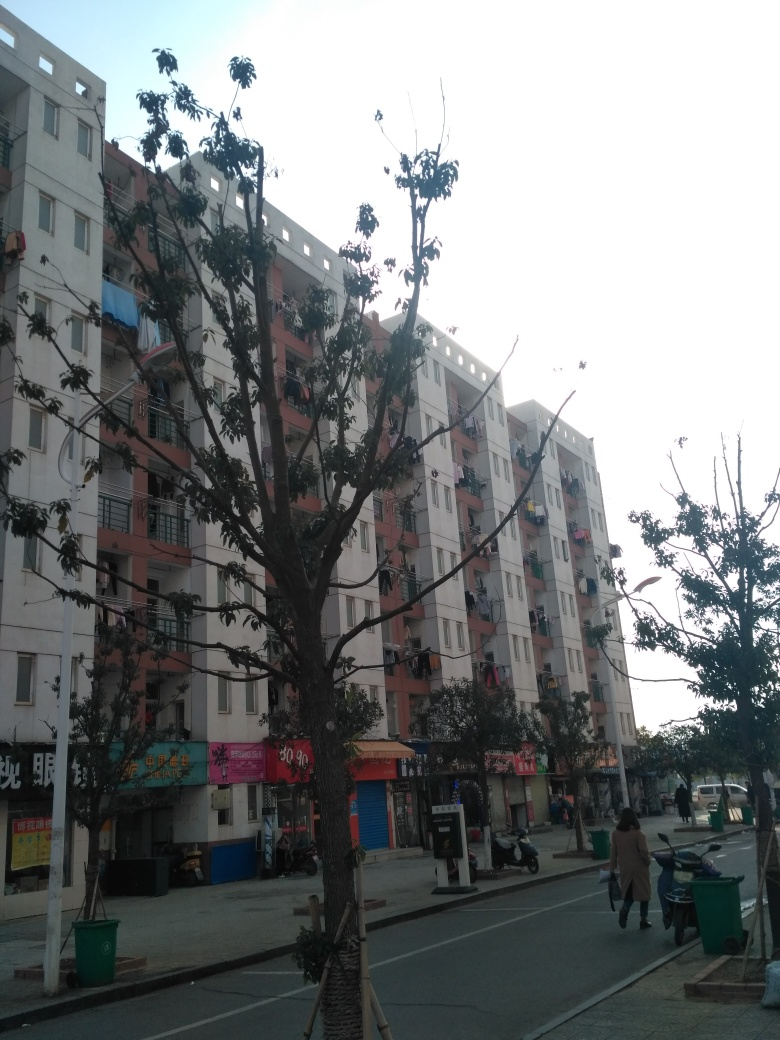What time of day does it appear to be in the image? Based on the lighting and shadows visible in the image, it seems to be early evening. The sky is still visibly bright, indicating that the sun may have recently set, which is further corroborated by the cool color tones and soft, diffused light. 